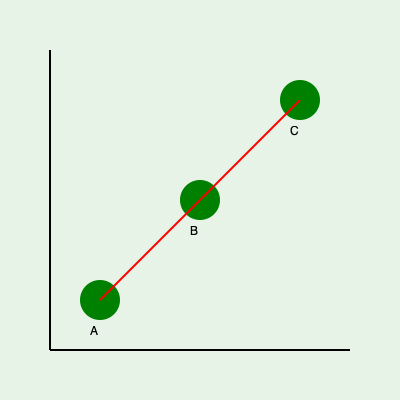Given the course map above, where A, B, and C represent consecutive golf holes, what is the most efficient path to play these holes, and what geometric principle supports this strategy? To determine the most efficient path through the golf holes, we need to consider the following steps:

1. Observe the layout: The holes A, B, and C form a right-angled triangle on the course map.

2. Identify the paths: 
   - Path 1: A → B → C (red curved line)
   - Path 2: A → C (straight line, not drawn)

3. Apply geometric principles:
   - The red curved line represents the path of playing each hole sequentially.
   - The straight line from A to C would represent the hypotenuse of the right-angled triangle.

4. Recall the Triangle Inequality Theorem: The sum of the lengths of any two sides of a triangle is always greater than the length of the remaining side.

5. Apply the theorem: In this case, AB + BC > AC

6. Interpret the result: The direct path from A to C (the hypotenuse) is shorter than the path going through B.

7. Consider golf strategy: While the straight line AC is geometrically shorter, in golf, we must play each hole. Therefore, the most efficient golf path is still A → B → C, despite it being a longer total distance.

8. Optimization: The most efficient golf path would minimize the distance between holes while still playing each one. This is represented by the red curved line, which shows smooth transitions between holes.
Answer: A → B → C; Triangle Inequality Theorem 